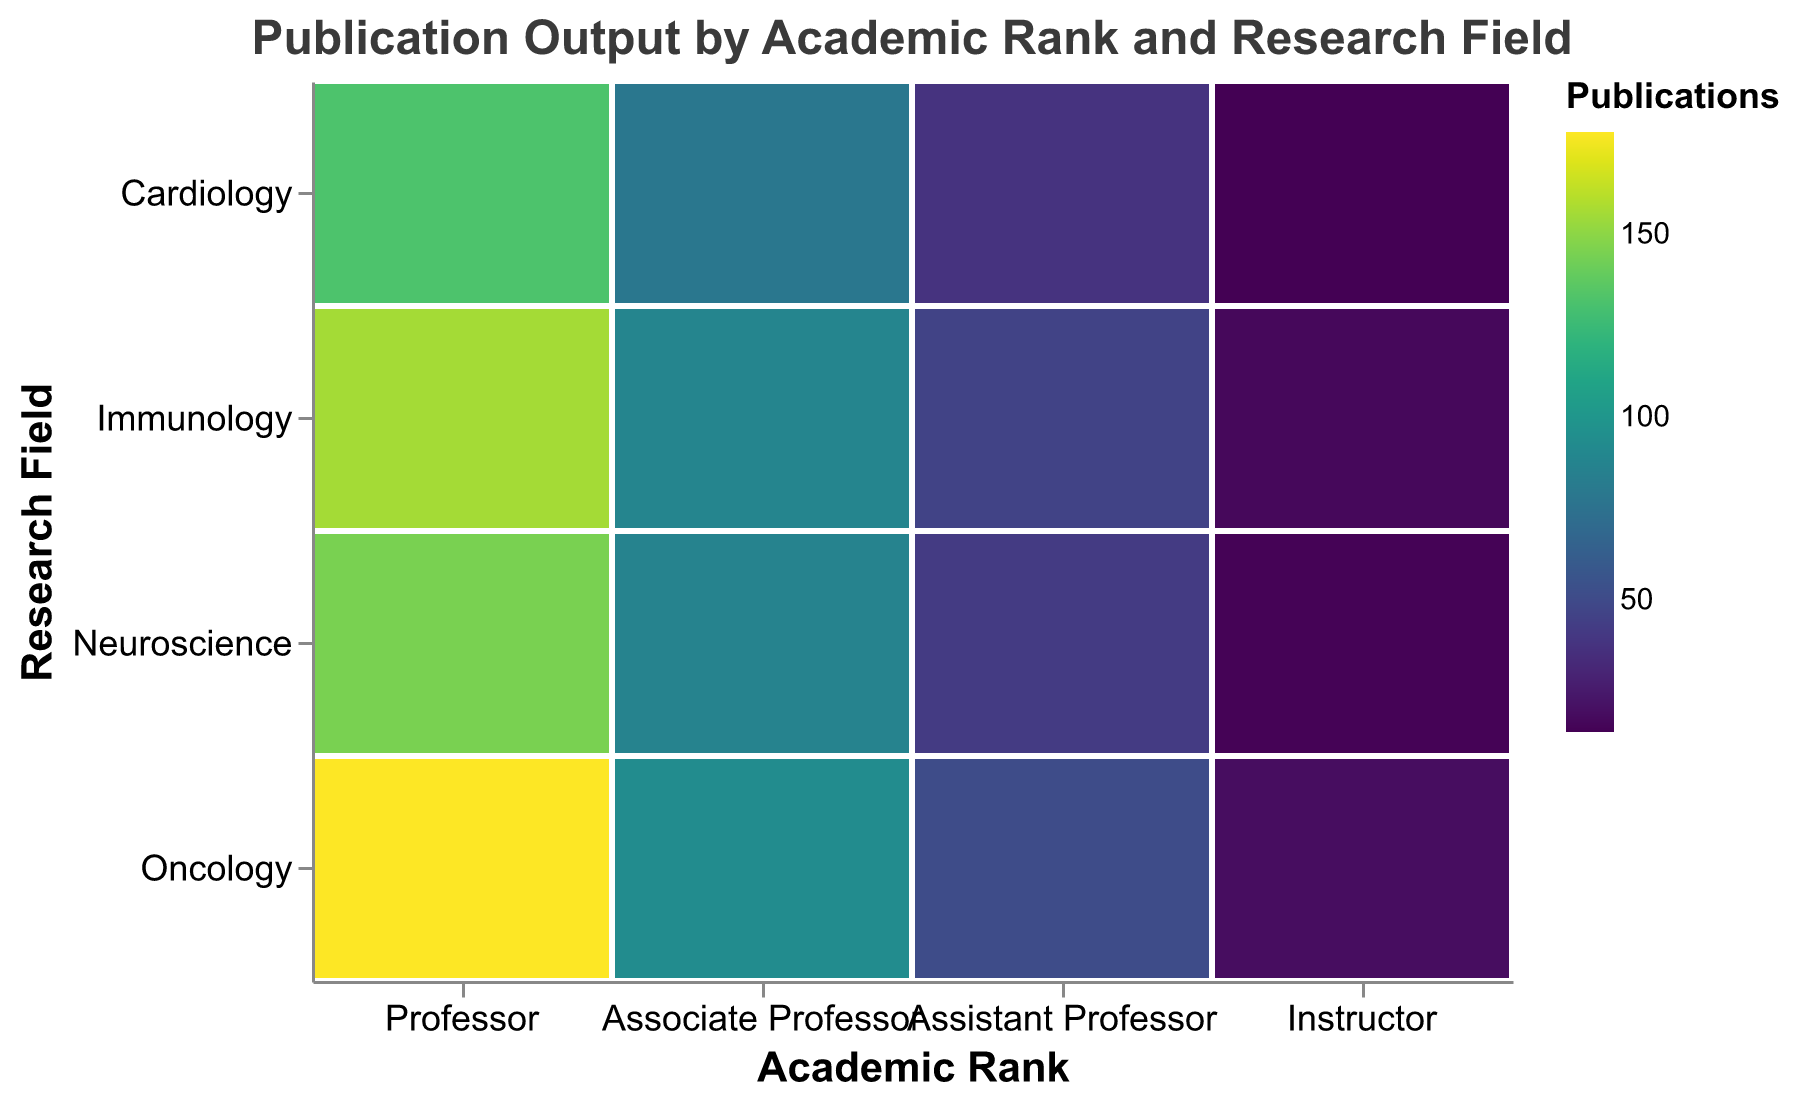Which academic rank has the highest publication output in Oncology? Observing the color gradient, the darkest hue in Oncology corresponding to Professors indicates the highest publication output.
Answer: Professor How many publications does the Assistant Professor rank have in Neuroscience? The color corresponding to Assistant Professor in Neuroscience shows the publication count as 42 based on the gradient.
Answer: 42 Which research field has the least amount of publications for Professors? By comparing the color gradients within the Professor rank, Cardiology appears to have the lightest color, indicating the lowest publication count.
Answer: Cardiology Is the publication output for Immunology higher for Associate Professors or Assistant Professors? Comparing the color shades of Immunology between Associate and Assistant Professors, the darker hue for Associate Professors shows a higher publication count.
Answer: Associate Professors Compare the publication count between Instructors in Neuroscience and Instructors in Oncology. By comparing the color gradients, both Neuroscience and Oncology for the Instructor rank: Neuroscience has 15 and Oncology has 19 publications.
Answer: Oncology has more publications Which academic rank has the most publications in Neuroscience? Observing the darkest color hue in Neuroscience, it corresponds to the Professor rank, indicating the highest publication count.
Answer: Professor What is the average publication output for all ranks in Cardiology? Summing the publications for all ranks in Cardiology: (132 + 79 + 38 + 14) = 263. There are 4 ranks, so the average is 263/4.
Answer: 65.75 Across all research fields, which has the highest range of publication counts among Professors? The highest and lowest values for Professors are found in Oncology (178) and Cardiology (132). The range is 178 - 132.
Answer: 46 In Neuroscience, which rank has a larger publication output difference, Professors and Associate Professors, or Associate Professors and Assistant Professors? The differences are: Professors and Associate Professors (145 - 87 = 58), Associate Professors and Assistant Professors (87 - 42 = 45).
Answer: Professors and Associate Professors Which academic rank has the lowest overall publication output across all research fields? Aggregating publication outputs per rank: Instructor has the smallest sum of publications.
Answer: Instructor 